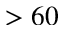<formula> <loc_0><loc_0><loc_500><loc_500>> 6 0</formula> 